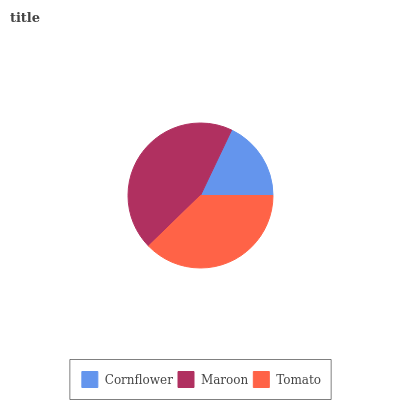Is Cornflower the minimum?
Answer yes or no. Yes. Is Maroon the maximum?
Answer yes or no. Yes. Is Tomato the minimum?
Answer yes or no. No. Is Tomato the maximum?
Answer yes or no. No. Is Maroon greater than Tomato?
Answer yes or no. Yes. Is Tomato less than Maroon?
Answer yes or no. Yes. Is Tomato greater than Maroon?
Answer yes or no. No. Is Maroon less than Tomato?
Answer yes or no. No. Is Tomato the high median?
Answer yes or no. Yes. Is Tomato the low median?
Answer yes or no. Yes. Is Cornflower the high median?
Answer yes or no. No. Is Cornflower the low median?
Answer yes or no. No. 